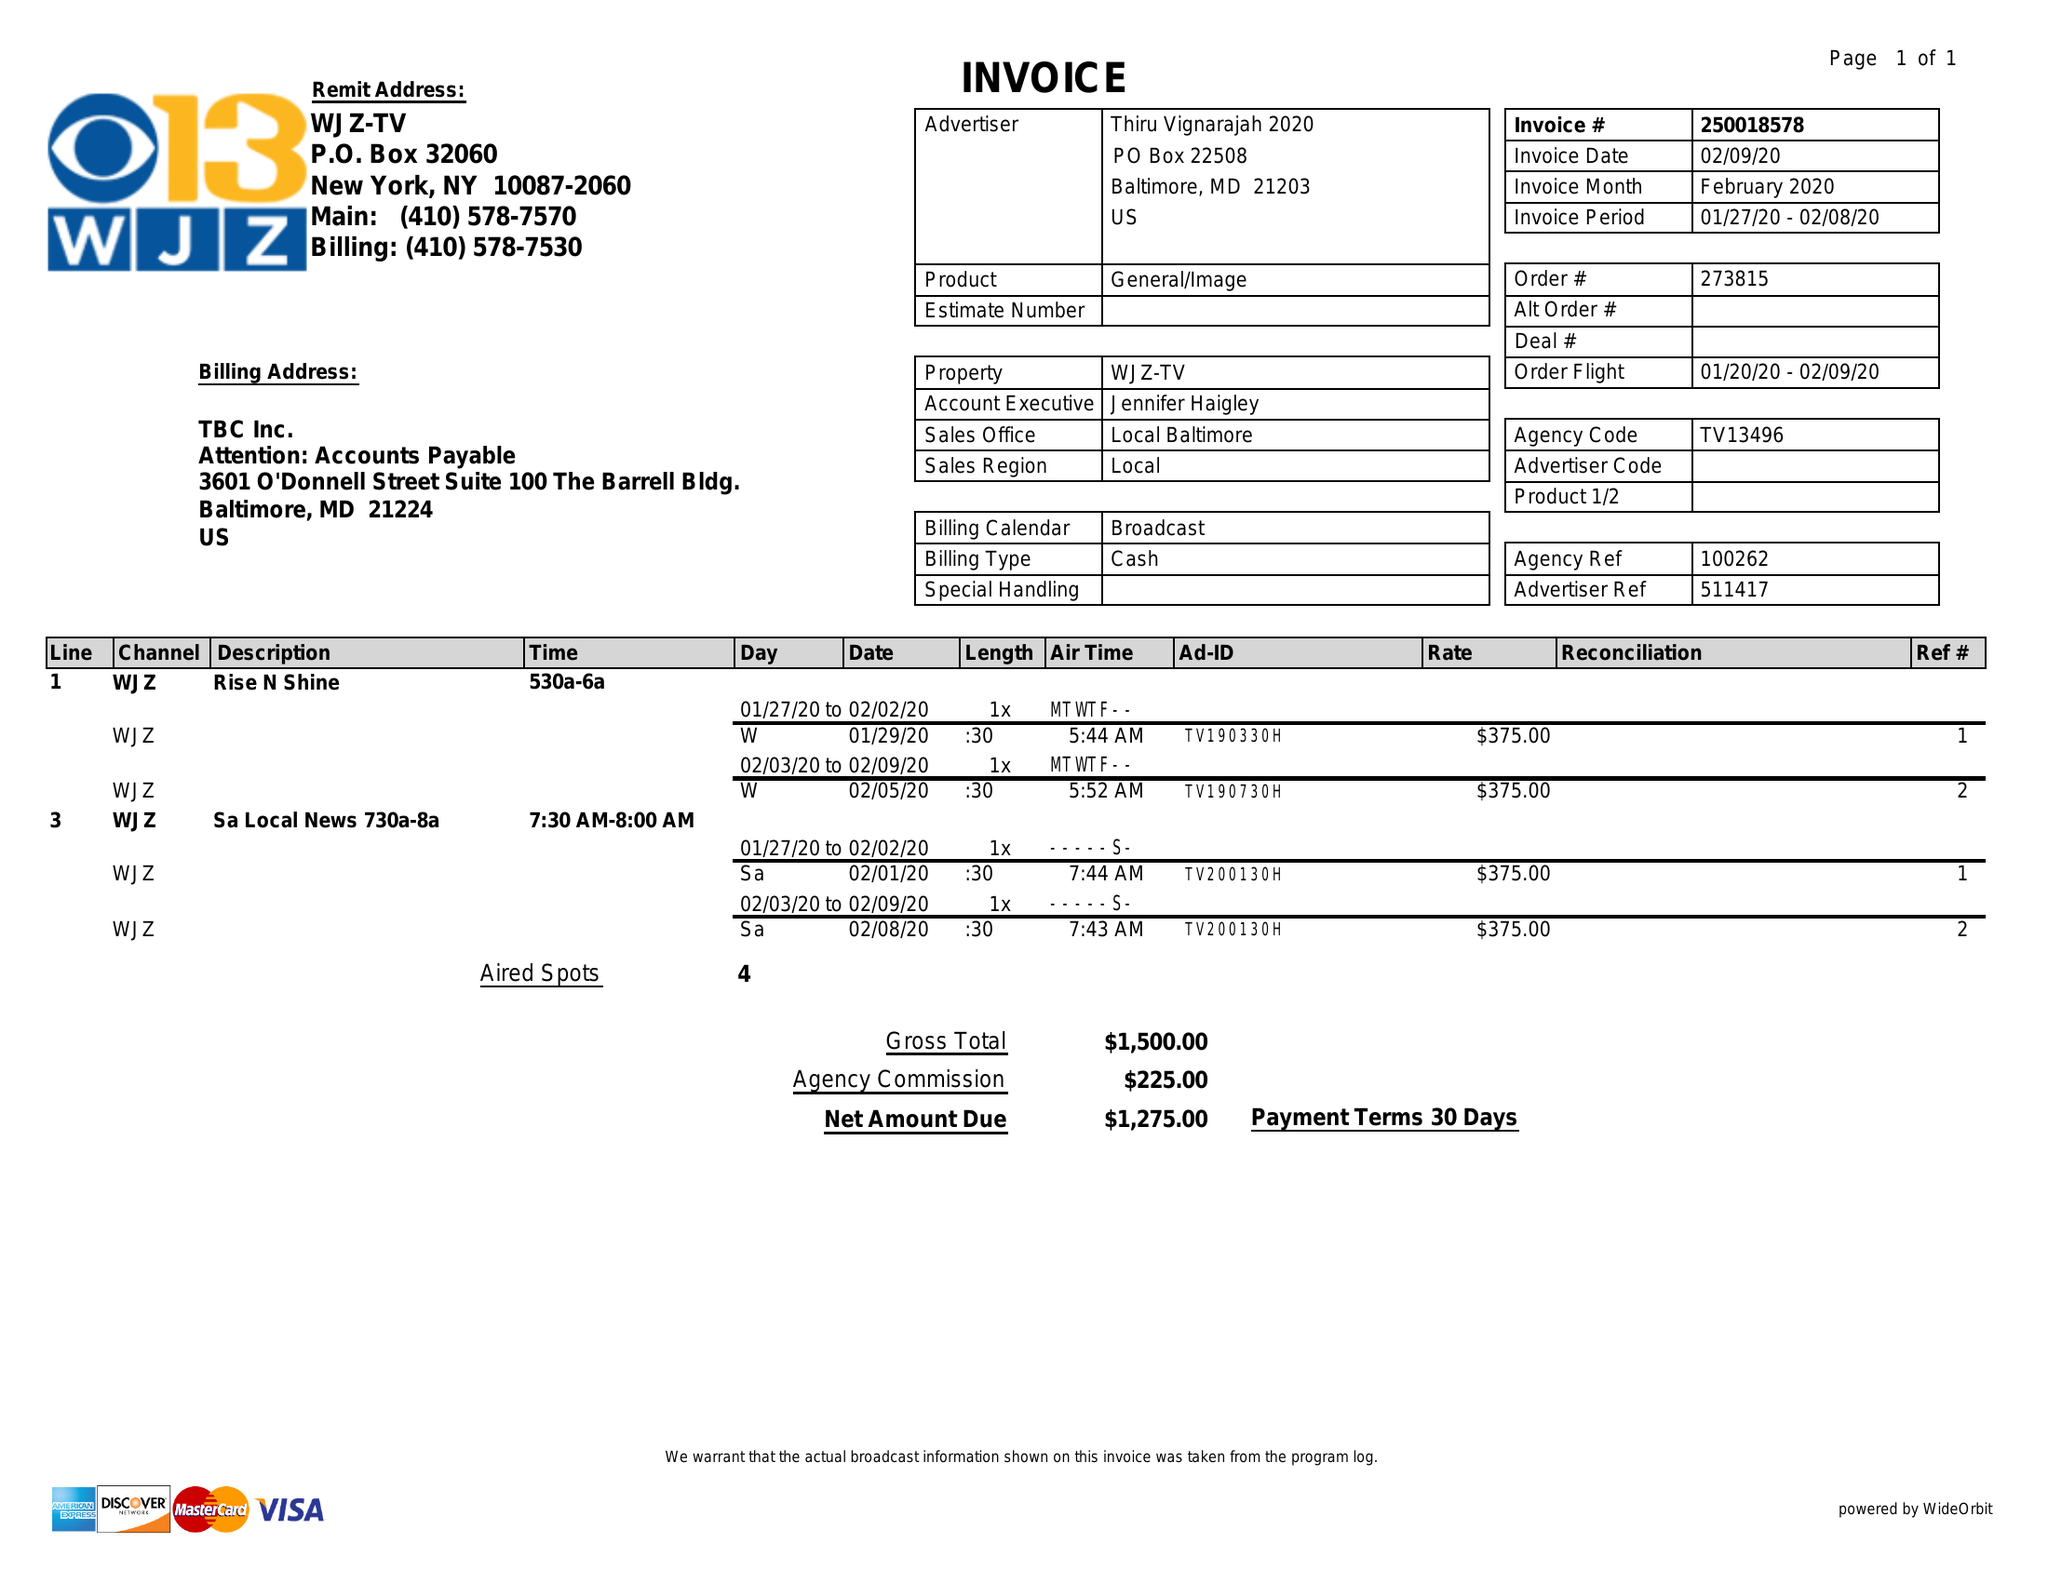What is the value for the flight_to?
Answer the question using a single word or phrase. 02/09/20 